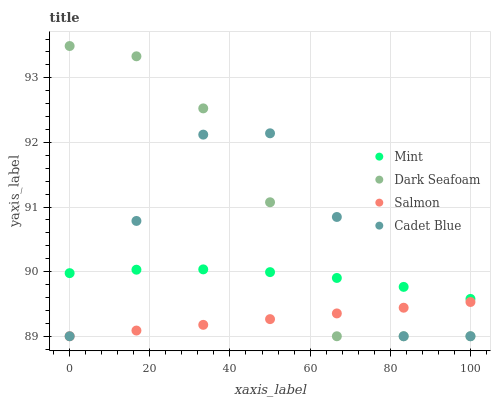Does Salmon have the minimum area under the curve?
Answer yes or no. Yes. Does Dark Seafoam have the maximum area under the curve?
Answer yes or no. Yes. Does Cadet Blue have the minimum area under the curve?
Answer yes or no. No. Does Cadet Blue have the maximum area under the curve?
Answer yes or no. No. Is Salmon the smoothest?
Answer yes or no. Yes. Is Cadet Blue the roughest?
Answer yes or no. Yes. Is Dark Seafoam the smoothest?
Answer yes or no. No. Is Dark Seafoam the roughest?
Answer yes or no. No. Does Salmon have the lowest value?
Answer yes or no. Yes. Does Mint have the lowest value?
Answer yes or no. No. Does Dark Seafoam have the highest value?
Answer yes or no. Yes. Does Cadet Blue have the highest value?
Answer yes or no. No. Is Salmon less than Mint?
Answer yes or no. Yes. Is Mint greater than Salmon?
Answer yes or no. Yes. Does Cadet Blue intersect Mint?
Answer yes or no. Yes. Is Cadet Blue less than Mint?
Answer yes or no. No. Is Cadet Blue greater than Mint?
Answer yes or no. No. Does Salmon intersect Mint?
Answer yes or no. No. 